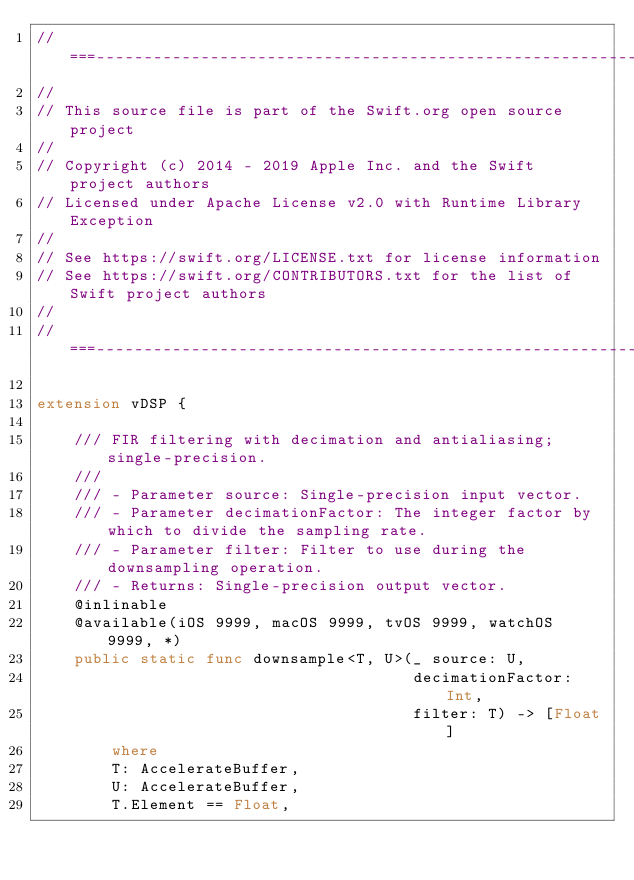<code> <loc_0><loc_0><loc_500><loc_500><_Swift_>//===----------------------------------------------------------------------===//
//
// This source file is part of the Swift.org open source project
//
// Copyright (c) 2014 - 2019 Apple Inc. and the Swift project authors
// Licensed under Apache License v2.0 with Runtime Library Exception
//
// See https://swift.org/LICENSE.txt for license information
// See https://swift.org/CONTRIBUTORS.txt for the list of Swift project authors
//
//===----------------------------------------------------------------------===//

extension vDSP {
    
    /// FIR filtering with decimation and antialiasing; single-precision.
    ///
    /// - Parameter source: Single-precision input vector.
    /// - Parameter decimationFactor: The integer factor by which to divide the sampling rate.
    /// - Parameter filter: Filter to use during the downsampling operation.
    /// - Returns: Single-precision output vector.
    @inlinable
    @available(iOS 9999, macOS 9999, tvOS 9999, watchOS 9999, *)
    public static func downsample<T, U>(_ source: U,
                                        decimationFactor: Int,
                                        filter: T) -> [Float]
        where
        T: AccelerateBuffer,
        U: AccelerateBuffer,
        T.Element == Float,</code> 